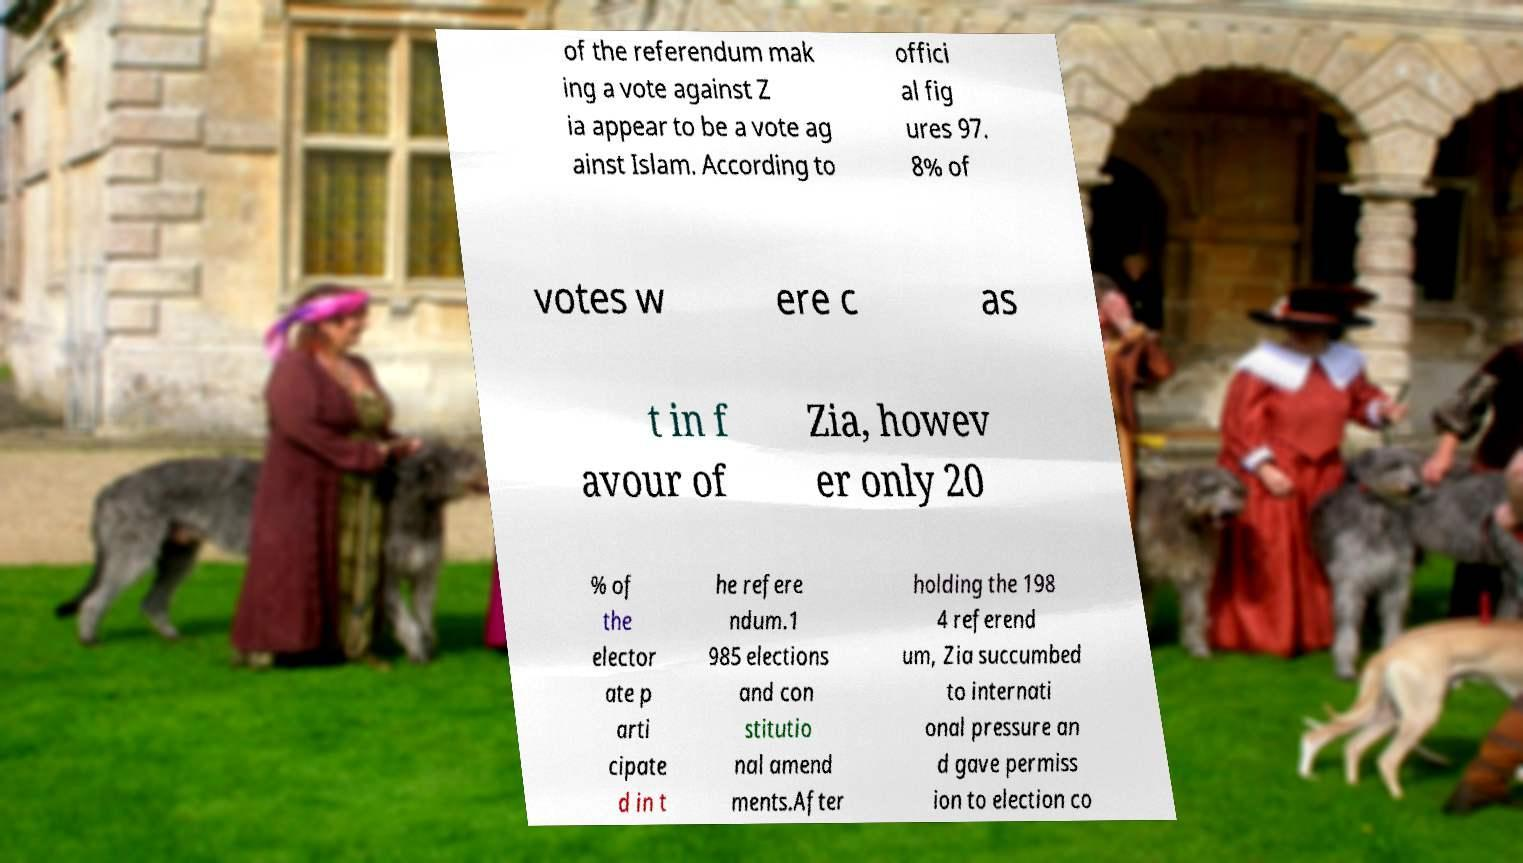Could you extract and type out the text from this image? of the referendum mak ing a vote against Z ia appear to be a vote ag ainst Islam. According to offici al fig ures 97. 8% of votes w ere c as t in f avour of Zia, howev er only 20 % of the elector ate p arti cipate d in t he refere ndum.1 985 elections and con stitutio nal amend ments.After holding the 198 4 referend um, Zia succumbed to internati onal pressure an d gave permiss ion to election co 